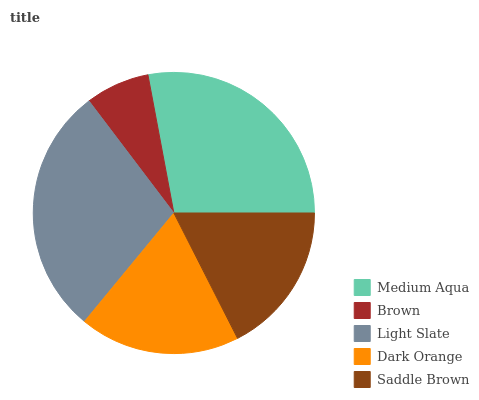Is Brown the minimum?
Answer yes or no. Yes. Is Light Slate the maximum?
Answer yes or no. Yes. Is Light Slate the minimum?
Answer yes or no. No. Is Brown the maximum?
Answer yes or no. No. Is Light Slate greater than Brown?
Answer yes or no. Yes. Is Brown less than Light Slate?
Answer yes or no. Yes. Is Brown greater than Light Slate?
Answer yes or no. No. Is Light Slate less than Brown?
Answer yes or no. No. Is Dark Orange the high median?
Answer yes or no. Yes. Is Dark Orange the low median?
Answer yes or no. Yes. Is Saddle Brown the high median?
Answer yes or no. No. Is Light Slate the low median?
Answer yes or no. No. 